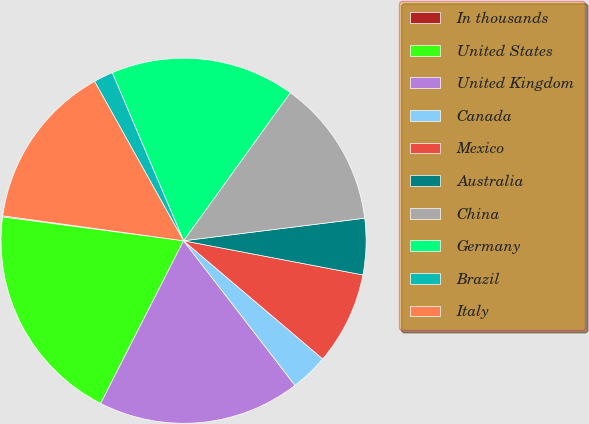Convert chart to OTSL. <chart><loc_0><loc_0><loc_500><loc_500><pie_chart><fcel>In thousands<fcel>United States<fcel>United Kingdom<fcel>Canada<fcel>Mexico<fcel>Australia<fcel>China<fcel>Germany<fcel>Brazil<fcel>Italy<nl><fcel>0.1%<fcel>19.58%<fcel>17.95%<fcel>3.34%<fcel>8.21%<fcel>4.97%<fcel>13.08%<fcel>16.33%<fcel>1.72%<fcel>14.71%<nl></chart> 